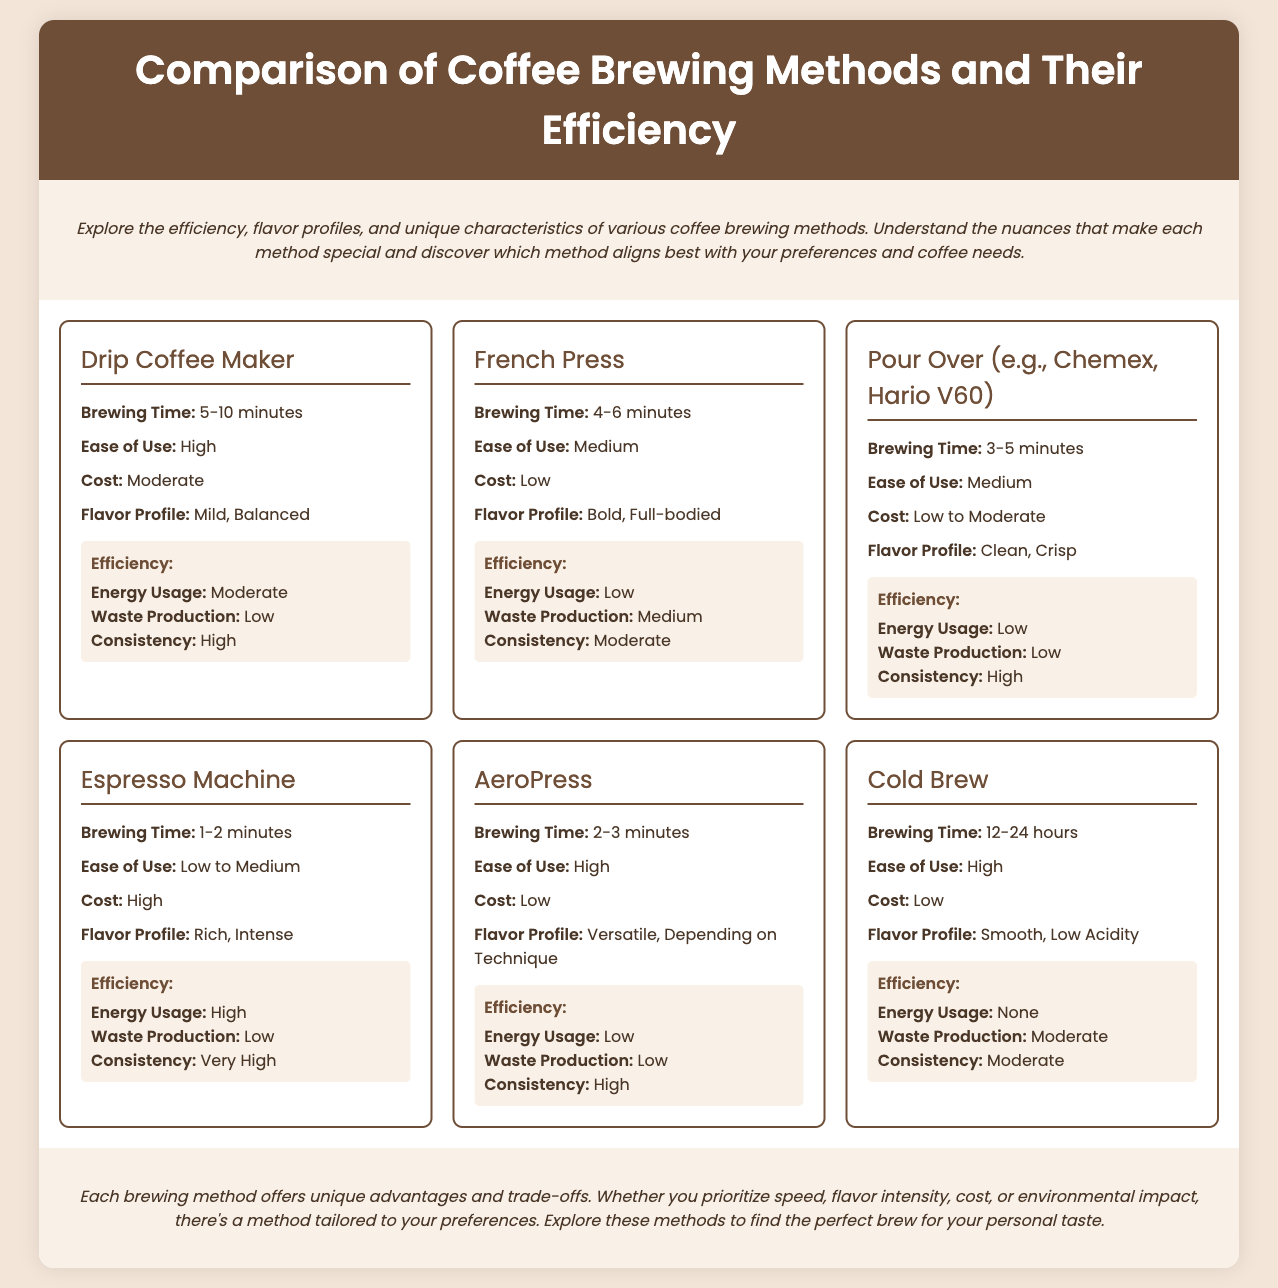What is the brewing time for French Press? The document states that the brewing time for French Press is between 4-6 minutes.
Answer: 4-6 minutes Which coffee brewing method has the highest energy usage? According to the infographic, the Espresso Machine has a high energy usage.
Answer: Espresso Machine What is the flavor profile of Pour Over? The flavor profile for Pour Over is described as clean and crisp in the document.
Answer: Clean, Crisp How does the consistency of Drip Coffee Maker compare to that of Cold Brew? The information shows that Drip Coffee Maker has high consistency, whereas Cold Brew has moderate consistency.
Answer: Higher What is the cost associated with the Espresso Machine? The cost of the Espresso Machine is categorized as high in the document.
Answer: High Which brewing method has no energy usage? The Cold Brew method is noted for having no energy usage per the comparison.
Answer: Cold Brew What is the waste production level for the French Press? The infographic indicates that waste production for the French Press is medium.
Answer: Medium What brewing method is rated as having high ease of use? The Drip Coffee Maker and AeroPress are both rated as having high ease of use according to the infographic.
Answer: Drip Coffee Maker and AeroPress 